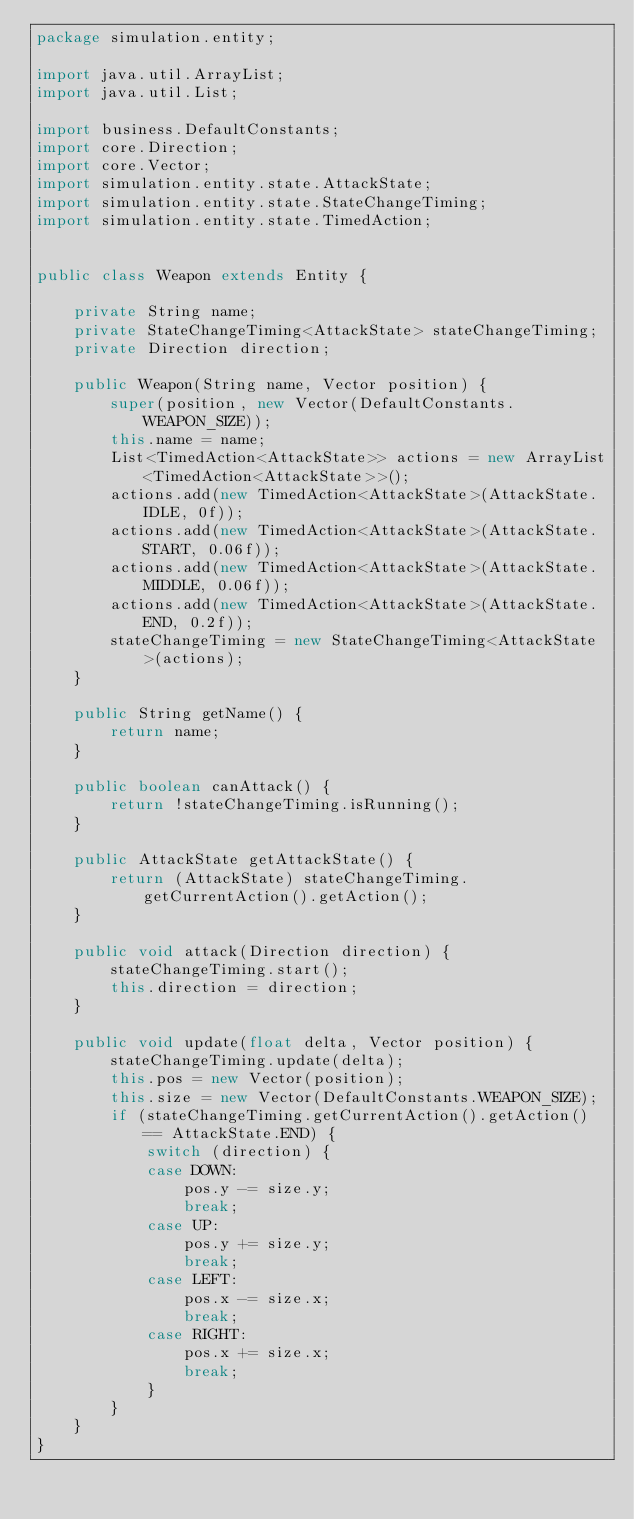Convert code to text. <code><loc_0><loc_0><loc_500><loc_500><_Java_>package simulation.entity;

import java.util.ArrayList;
import java.util.List;

import business.DefaultConstants;
import core.Direction;
import core.Vector;
import simulation.entity.state.AttackState;
import simulation.entity.state.StateChangeTiming;
import simulation.entity.state.TimedAction;


public class Weapon extends Entity {

	private String name;
	private StateChangeTiming<AttackState> stateChangeTiming;
	private Direction direction;
	
	public Weapon(String name, Vector position) {
		super(position, new Vector(DefaultConstants.WEAPON_SIZE));
		this.name = name;
		List<TimedAction<AttackState>> actions = new ArrayList<TimedAction<AttackState>>();
		actions.add(new TimedAction<AttackState>(AttackState.IDLE, 0f));
		actions.add(new TimedAction<AttackState>(AttackState.START, 0.06f));
		actions.add(new TimedAction<AttackState>(AttackState.MIDDLE, 0.06f));
		actions.add(new TimedAction<AttackState>(AttackState.END, 0.2f));
		stateChangeTiming = new StateChangeTiming<AttackState>(actions);
	}
	
	public String getName() {
		return name;
	}
	
	public boolean canAttack() {
		return !stateChangeTiming.isRunning();
	}
	
	public AttackState getAttackState() {
		return (AttackState) stateChangeTiming.getCurrentAction().getAction();
	}
	
	public void attack(Direction direction) {
		stateChangeTiming.start();
		this.direction = direction;
	}
	
	public void update(float delta, Vector position) {
		stateChangeTiming.update(delta);
		this.pos = new Vector(position);
		this.size = new Vector(DefaultConstants.WEAPON_SIZE);
		if (stateChangeTiming.getCurrentAction().getAction() == AttackState.END) {
			switch (direction) {
			case DOWN:
				pos.y -= size.y;
				break;
			case UP:
				pos.y += size.y;
				break;
			case LEFT:
				pos.x -= size.x;
				break;
			case RIGHT:
				pos.x += size.x;
				break;
			}
		}
	}
}
</code> 